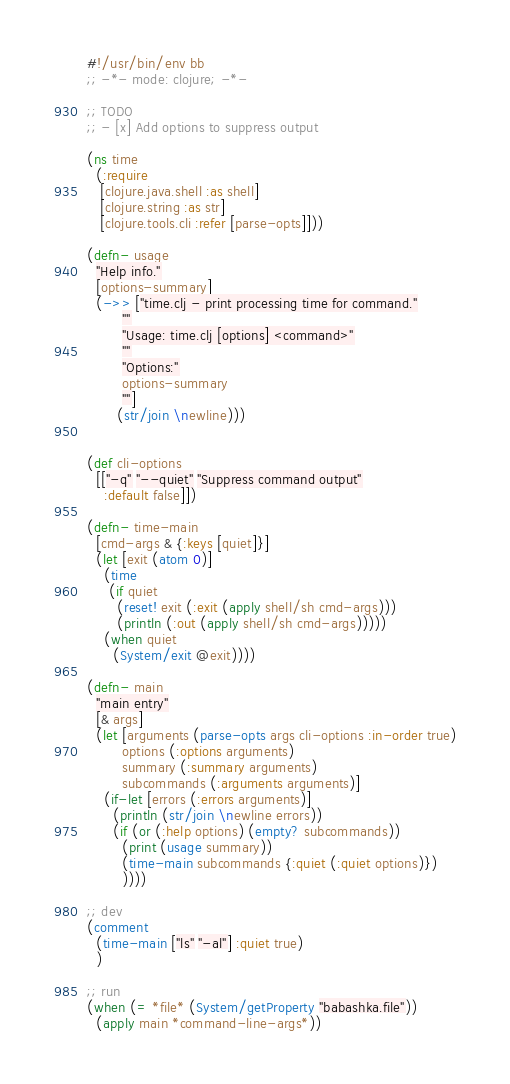<code> <loc_0><loc_0><loc_500><loc_500><_Clojure_>#!/usr/bin/env bb
;; -*- mode: clojure; -*-

;; TODO
;; - [x] Add options to suppress output

(ns time
  (:require
   [clojure.java.shell :as shell]
   [clojure.string :as str]
   [clojure.tools.cli :refer [parse-opts]]))

(defn- usage
  "Help info."
  [options-summary]
  (->> ["time.clj - print processing time for command."
        ""
        "Usage: time.clj [options] <command>"
        ""
        "Options:"
        options-summary
        ""]
       (str/join \newline)))


(def cli-options
  [["-q" "--quiet" "Suppress command output"
    :default false]])

(defn- time-main
  [cmd-args & {:keys [quiet]}]
  (let [exit (atom 0)]
    (time
     (if quiet
       (reset! exit (:exit (apply shell/sh cmd-args)))
       (println (:out (apply shell/sh cmd-args)))))
    (when quiet
      (System/exit @exit))))

(defn- main
  "main entry"
  [& args]
  (let [arguments (parse-opts args cli-options :in-order true)
        options (:options arguments)
        summary (:summary arguments)
        subcommands (:arguments arguments)]
    (if-let [errors (:errors arguments)]
      (println (str/join \newline errors))
      (if (or (:help options) (empty? subcommands))
        (print (usage summary))
        (time-main subcommands {:quiet (:quiet options)})
        ))))

;; dev
(comment
  (time-main ["ls" "-al"] :quiet true)
  )

;; run
(when (= *file* (System/getProperty "babashka.file"))
  (apply main *command-line-args*))
</code> 